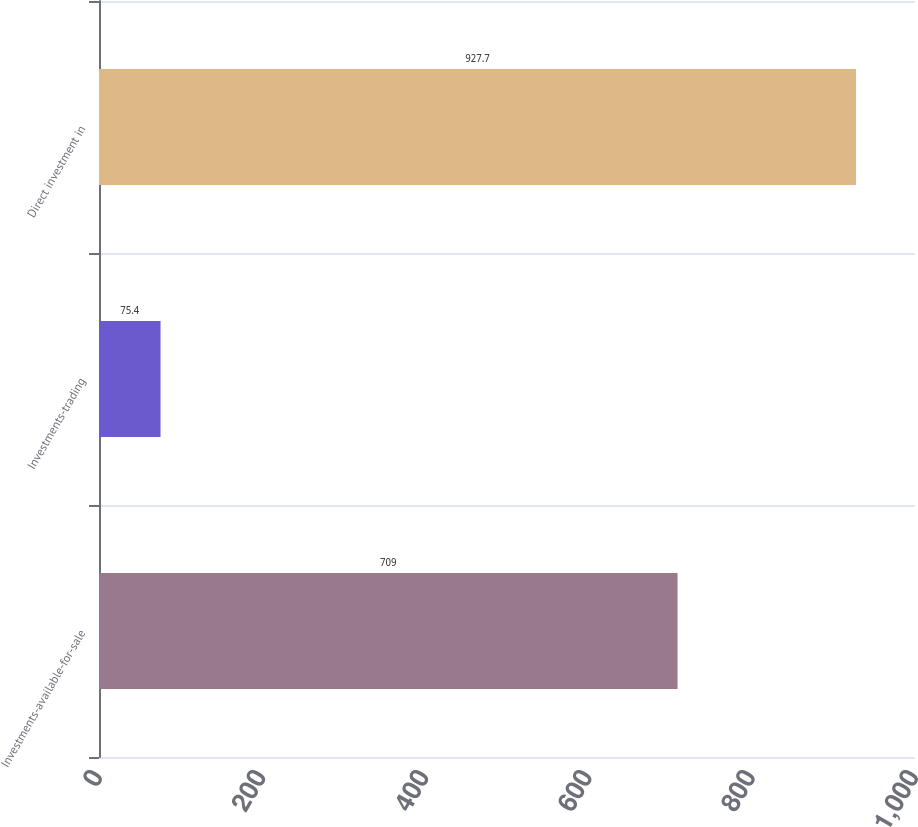Convert chart. <chart><loc_0><loc_0><loc_500><loc_500><bar_chart><fcel>Investments-available-for-sale<fcel>Investments-trading<fcel>Direct investment in<nl><fcel>709<fcel>75.4<fcel>927.7<nl></chart> 